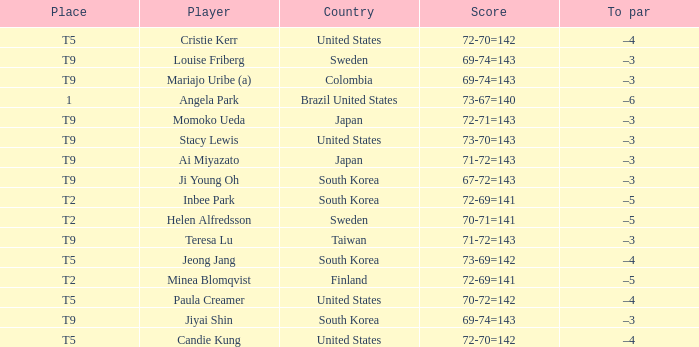What was Momoko Ueda's place? T9. 